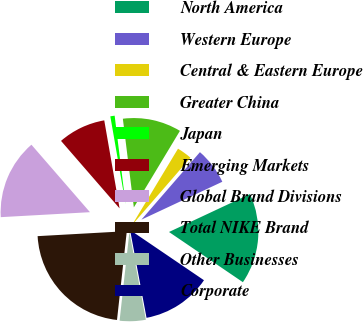Convert chart to OTSL. <chart><loc_0><loc_0><loc_500><loc_500><pie_chart><fcel>North America<fcel>Western Europe<fcel>Central & Eastern Europe<fcel>Greater China<fcel>Japan<fcel>Emerging Markets<fcel>Global Brand Divisions<fcel>Total NIKE Brand<fcel>Other Businesses<fcel>Corporate<nl><fcel>16.47%<fcel>6.66%<fcel>2.74%<fcel>10.59%<fcel>0.78%<fcel>8.63%<fcel>14.51%<fcel>22.36%<fcel>4.7%<fcel>12.55%<nl></chart> 